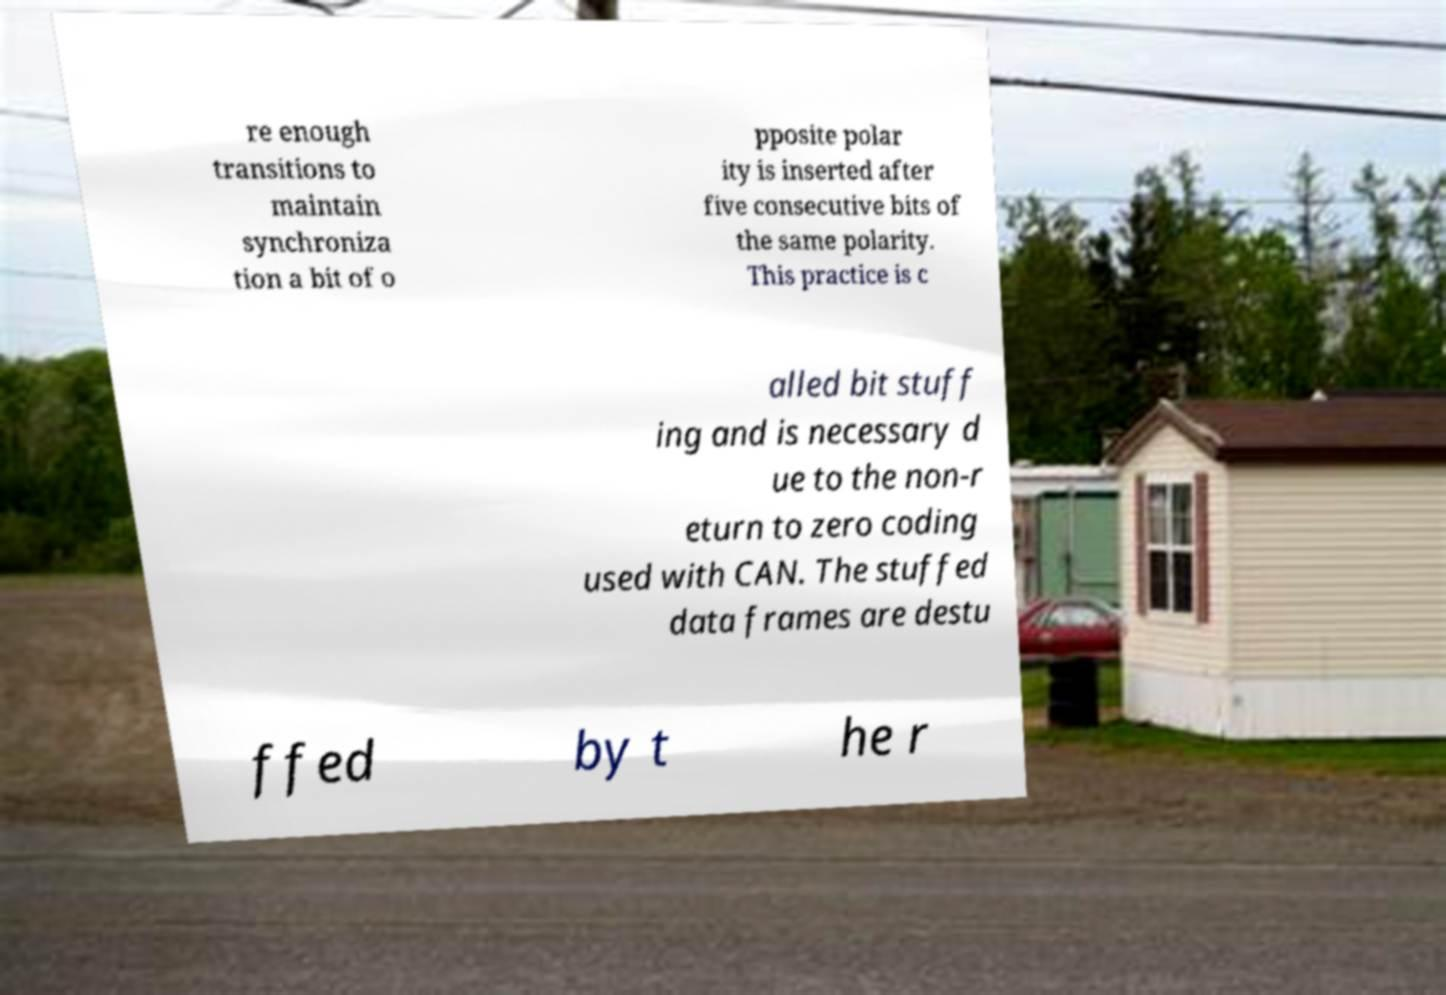There's text embedded in this image that I need extracted. Can you transcribe it verbatim? re enough transitions to maintain synchroniza tion a bit of o pposite polar ity is inserted after five consecutive bits of the same polarity. This practice is c alled bit stuff ing and is necessary d ue to the non-r eturn to zero coding used with CAN. The stuffed data frames are destu ffed by t he r 